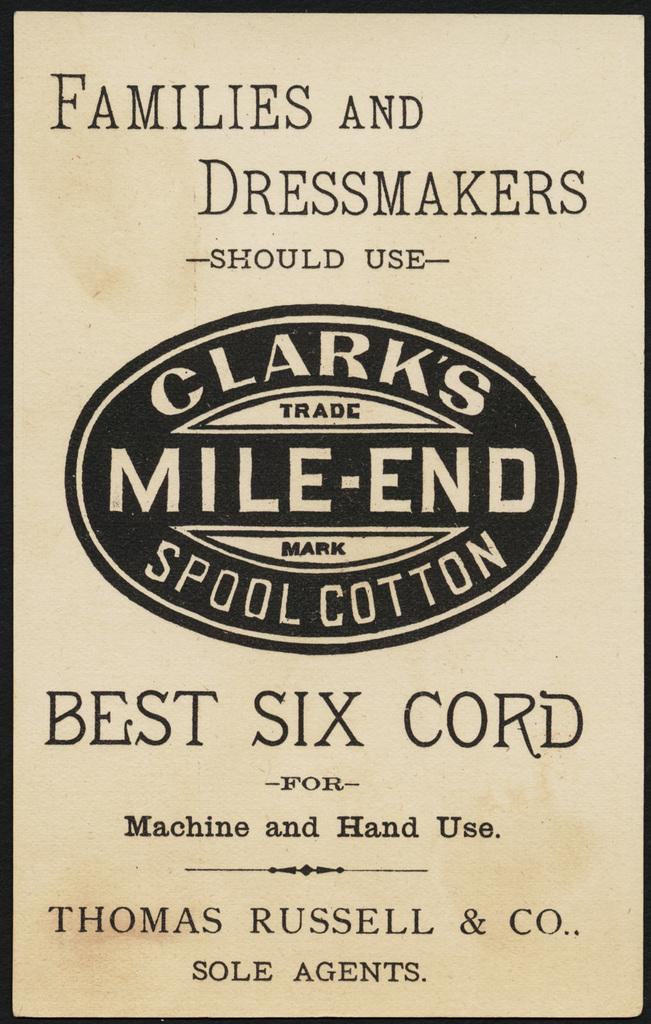<image>
Render a clear and concise summary of the photo. A book by Thomas Russell & Co. titled Families and Dressmakers. 